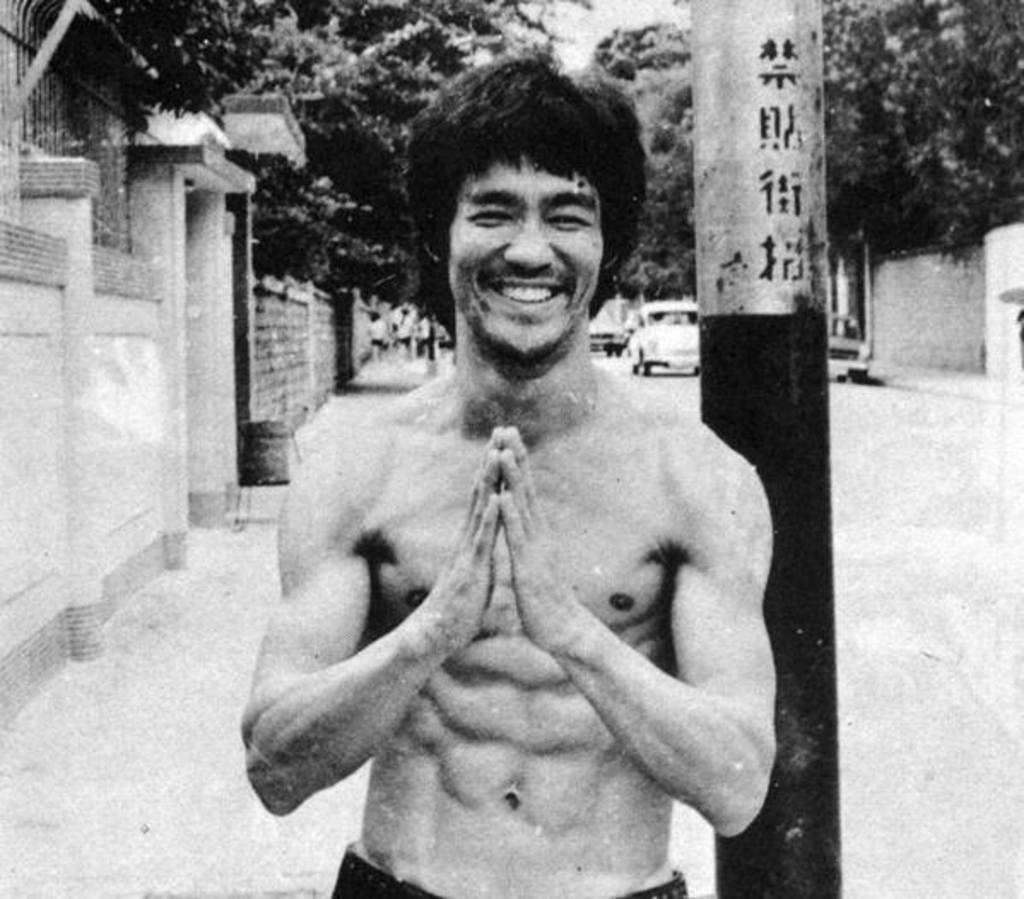Could you give a brief overview of what you see in this image? This is a black and white image. In the center of the image there is a person. In the background we can see pole, trees, cars, wall and road. 